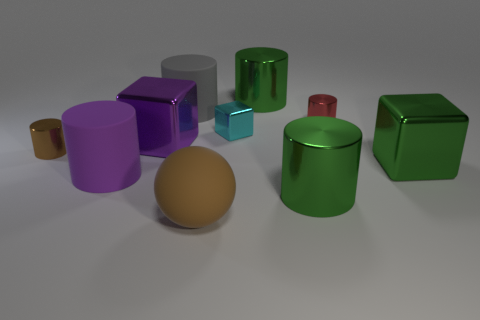The thing that is the same color as the ball is what shape?
Offer a very short reply. Cylinder. What number of brown cylinders have the same size as the brown shiny thing?
Give a very brief answer. 0. The big green metal thing that is behind the large gray object has what shape?
Give a very brief answer. Cylinder. Is the number of large rubber spheres less than the number of big rubber cylinders?
Provide a short and direct response. Yes. Are there any other things of the same color as the tiny metallic block?
Ensure brevity in your answer.  No. There is a metallic cube on the left side of the brown matte object; what is its size?
Your response must be concise. Large. Are there more brown shiny objects than tiny blue rubber blocks?
Your answer should be compact. Yes. What is the large gray cylinder made of?
Give a very brief answer. Rubber. How many other objects are the same material as the red object?
Provide a succinct answer. 6. How many red metal things are there?
Keep it short and to the point. 1. 